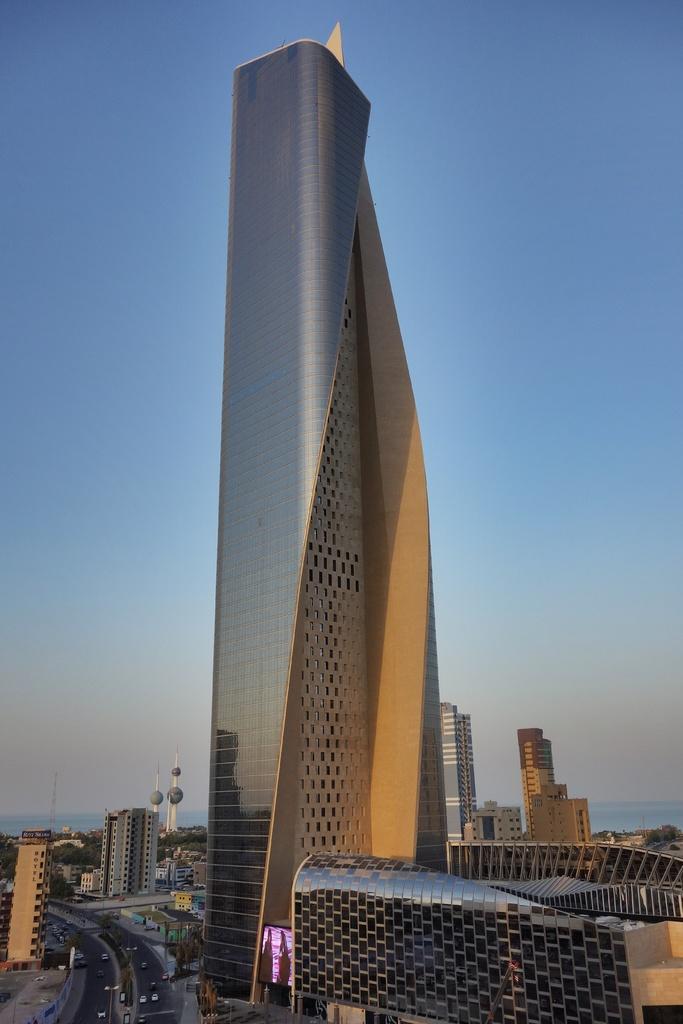Can you describe this image briefly? In the image we can see buildings and these are the windows of the building, there are many vehicles on the road, there is a tower, water and a pale blue color sky. 